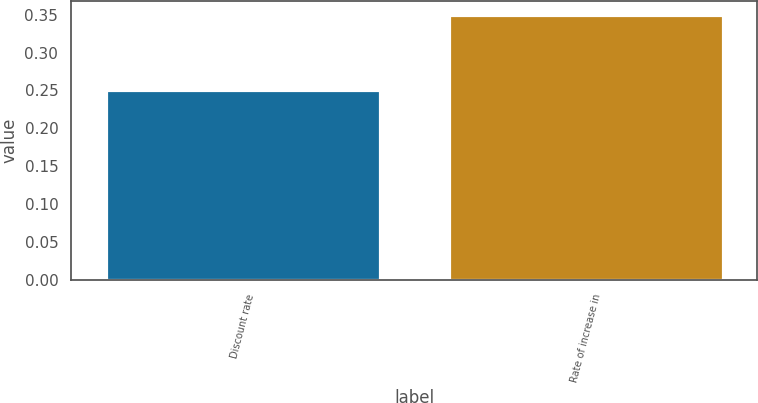Convert chart. <chart><loc_0><loc_0><loc_500><loc_500><bar_chart><fcel>Discount rate<fcel>Rate of increase in<nl><fcel>0.25<fcel>0.35<nl></chart> 